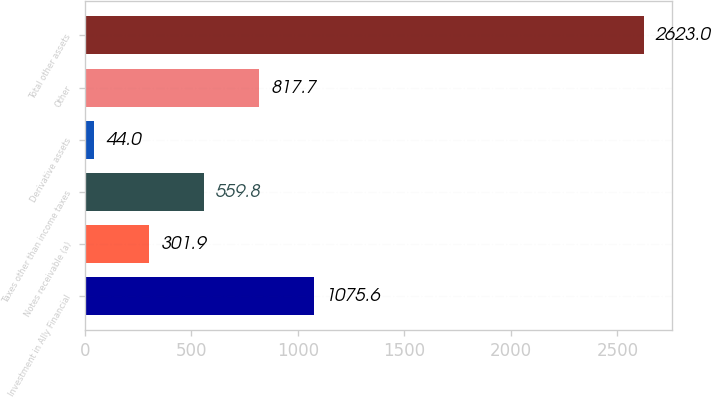Convert chart to OTSL. <chart><loc_0><loc_0><loc_500><loc_500><bar_chart><fcel>Investment in Ally Financial<fcel>Notes receivable (a)<fcel>Taxes other than income taxes<fcel>Derivative assets<fcel>Other<fcel>Total other assets<nl><fcel>1075.6<fcel>301.9<fcel>559.8<fcel>44<fcel>817.7<fcel>2623<nl></chart> 